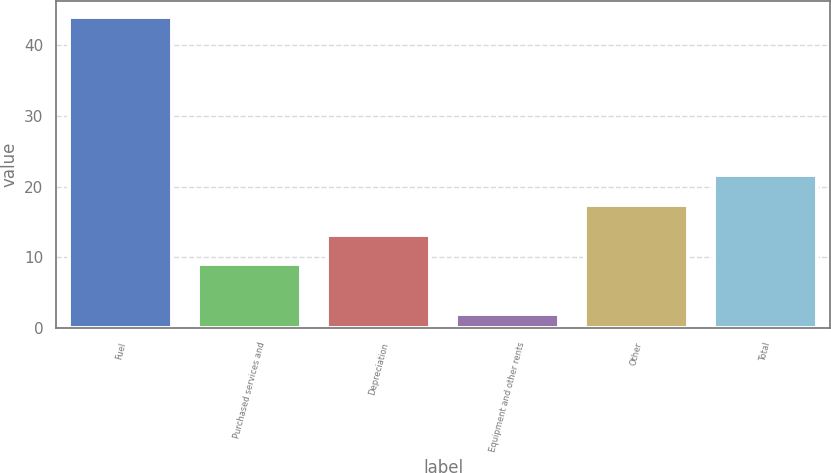<chart> <loc_0><loc_0><loc_500><loc_500><bar_chart><fcel>Fuel<fcel>Purchased services and<fcel>Depreciation<fcel>Equipment and other rents<fcel>Other<fcel>Total<nl><fcel>44<fcel>9<fcel>13.2<fcel>2<fcel>17.4<fcel>21.6<nl></chart> 